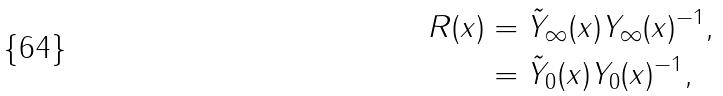<formula> <loc_0><loc_0><loc_500><loc_500>R ( x ) & = \tilde { Y } _ { \infty } ( x ) Y _ { \infty } ( x ) ^ { - 1 } , \\ & = \tilde { Y } _ { 0 } ( x ) Y _ { 0 } ( x ) ^ { - 1 } ,</formula> 